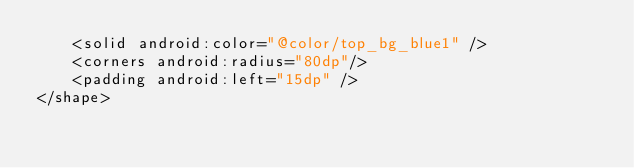<code> <loc_0><loc_0><loc_500><loc_500><_XML_>    <solid android:color="@color/top_bg_blue1" />
    <corners android:radius="80dp"/>
    <padding android:left="15dp" />
</shape>
</code> 